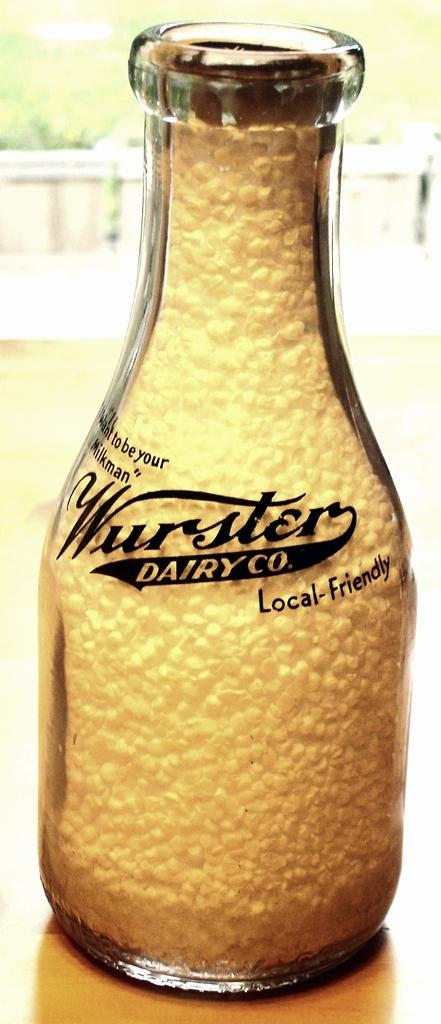Provide a one-sentence caption for the provided image. A Wurster Dairy Co. glass bottle on a wooden table. 